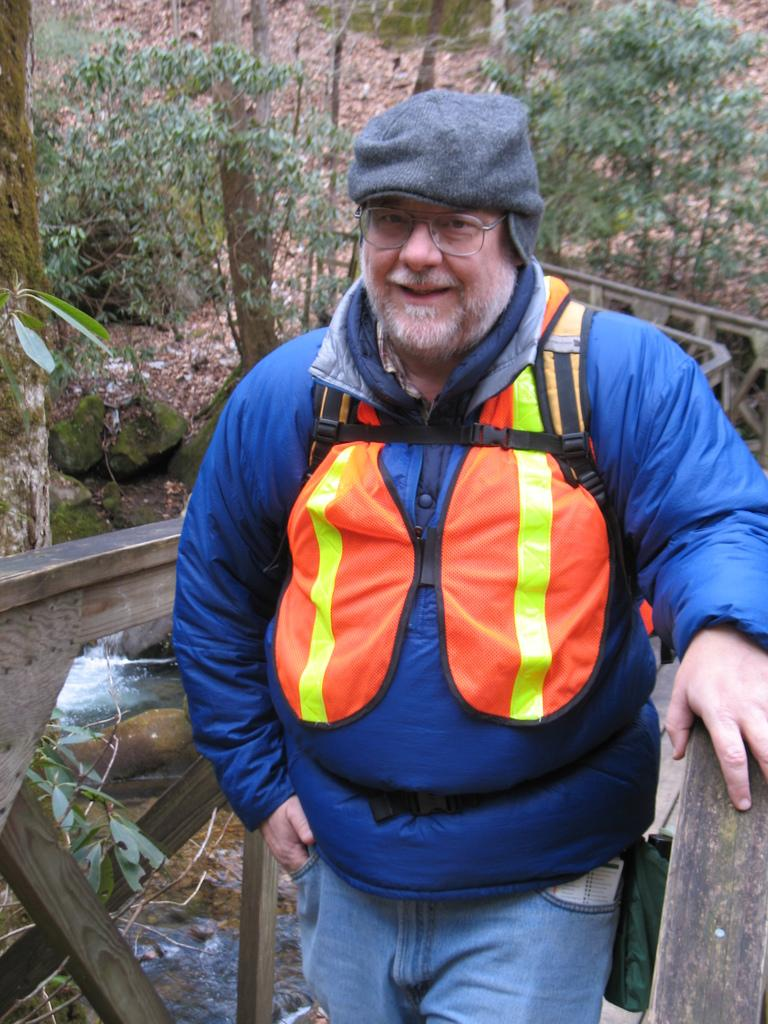What can be seen in the image related to a person? There is a person in the image, and they are wearing spectacles. Can you describe the surroundings of the person? The person may be in front of a fence, and there are trees, water, stones, and plants visible in the image. What color is the hot wall in the image? There is no hot wall present in the image. 